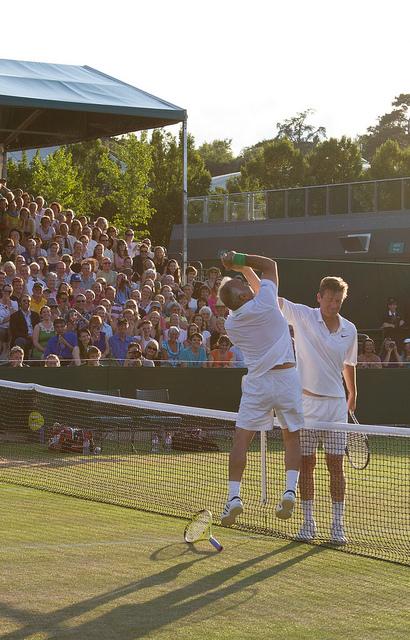Are there spectators to this match?
Be succinct. Yes. What is in between the two men?
Give a very brief answer. Net. Why is the man jumping?
Be succinct. Excited. Do the players appear cordial?
Keep it brief. Yes. 